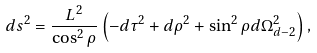Convert formula to latex. <formula><loc_0><loc_0><loc_500><loc_500>d s ^ { 2 } = \frac { L ^ { 2 } } { \cos ^ { 2 } \rho } \left ( - d \tau ^ { 2 } + d \rho ^ { 2 } + \sin ^ { 2 } \rho d \Omega _ { d - 2 } ^ { 2 } \right ) ,</formula> 